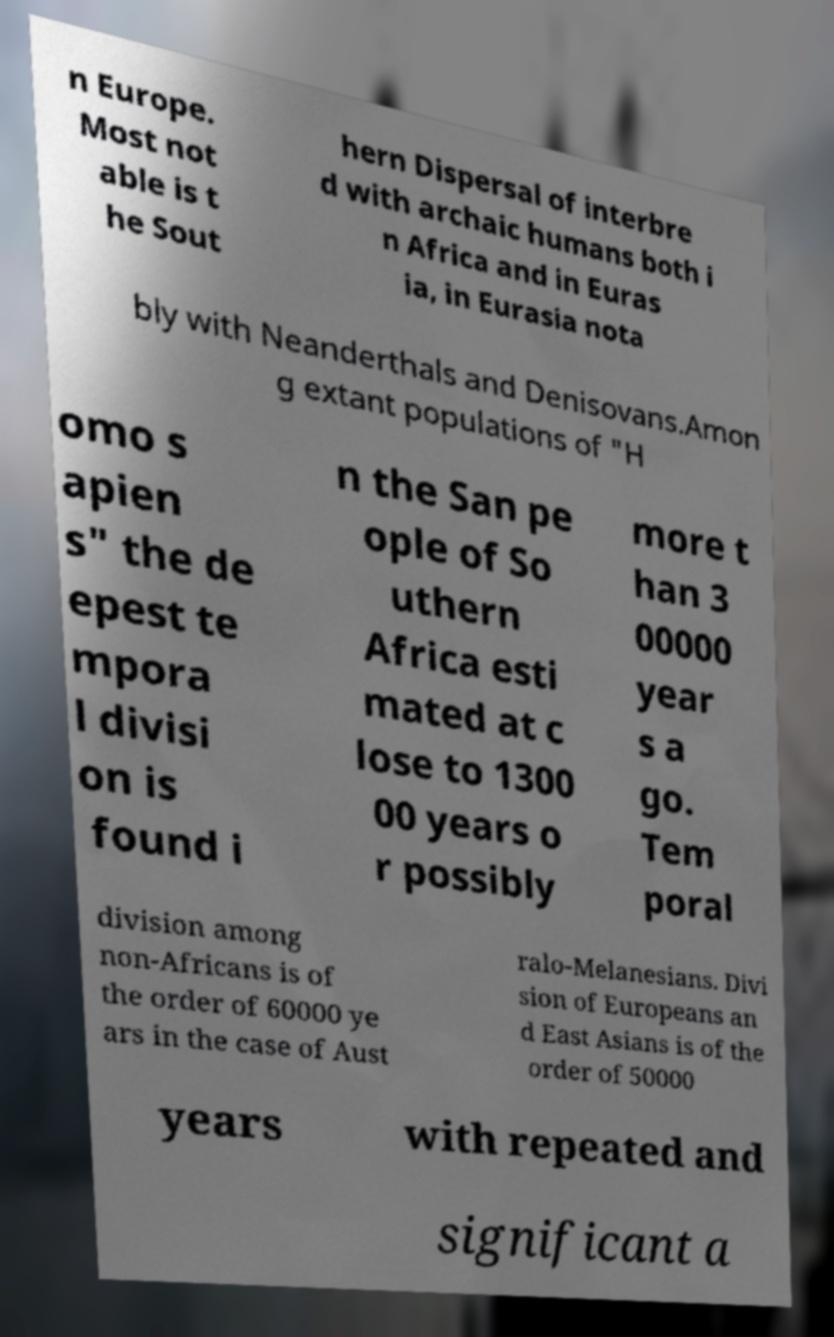Can you accurately transcribe the text from the provided image for me? n Europe. Most not able is t he Sout hern Dispersal of interbre d with archaic humans both i n Africa and in Euras ia, in Eurasia nota bly with Neanderthals and Denisovans.Amon g extant populations of "H omo s apien s" the de epest te mpora l divisi on is found i n the San pe ople of So uthern Africa esti mated at c lose to 1300 00 years o r possibly more t han 3 00000 year s a go. Tem poral division among non-Africans is of the order of 60000 ye ars in the case of Aust ralo-Melanesians. Divi sion of Europeans an d East Asians is of the order of 50000 years with repeated and significant a 